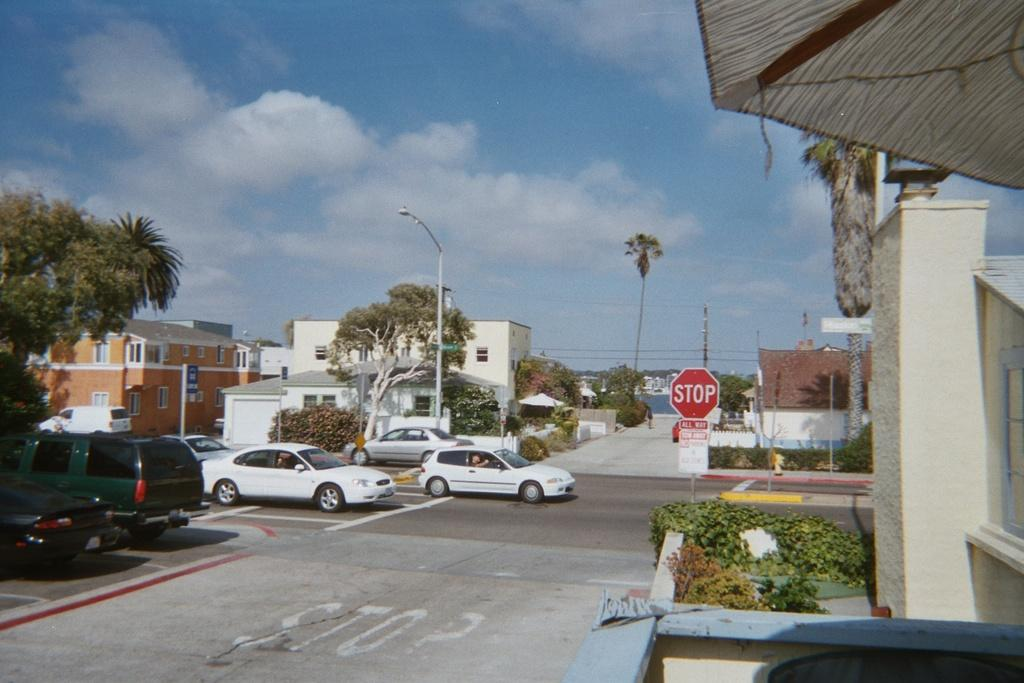What types of objects can be seen in the image? There are vehicles, poles, boards, buildings, plants, and trees in the image. Can you describe the structures in the image? There are buildings and poles in the image. What type of vegetation is present in the image? There are plants and trees in the image. What is visible in the background of the image? The sky is visible in the background of the image. What type of lumber is being used on the stage in the image? There is no stage or lumber present in the image. What show is being performed on the stage in the image? There is no stage or show present in the image. 